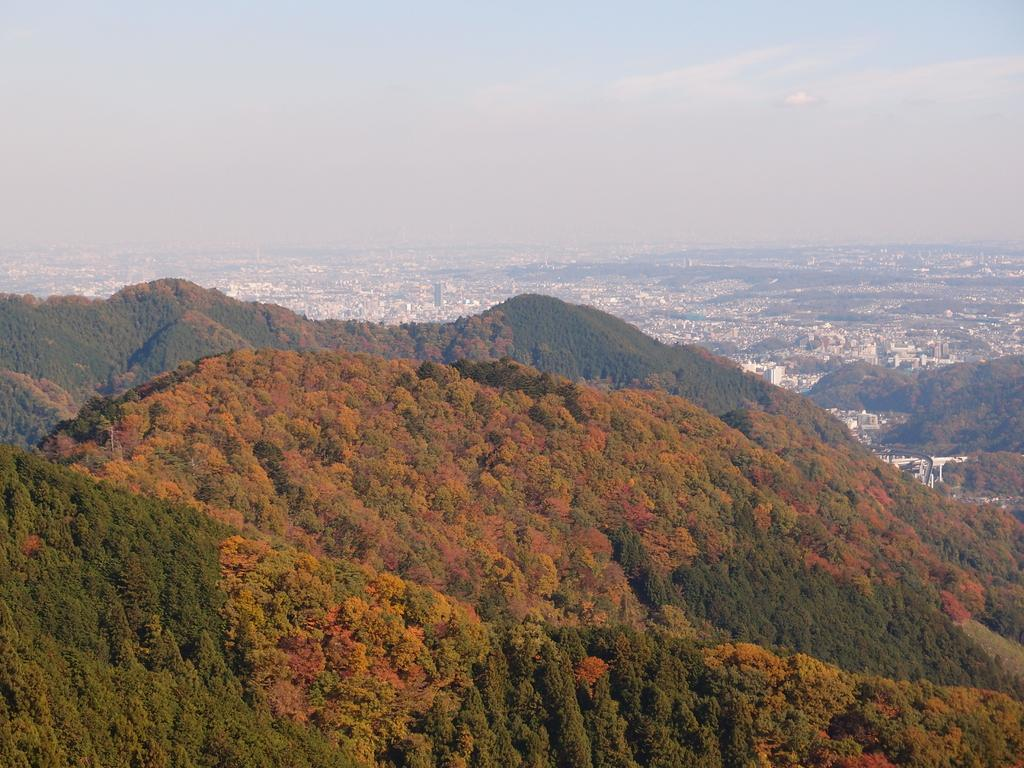What type of vegetation can be seen in the image? There are trees in the image. What colors are the trees in the image? The trees have various colors, including white-green, yellow, orange, and pink. What structures can be seen in the background of the image? There are houses in the background of the image. What is visible in the sky in the image? The sky is visible in the background of the image. What type of tray is being used to hold the knowledge in the image? There is no tray or knowledge present in the image; it features trees with various colors and houses in the background. 